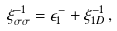<formula> <loc_0><loc_0><loc_500><loc_500>\xi _ { \sigma \sigma } ^ { - 1 } = \epsilon ^ { - } _ { 1 } + \xi _ { 1 D } ^ { - 1 } \, ,</formula> 